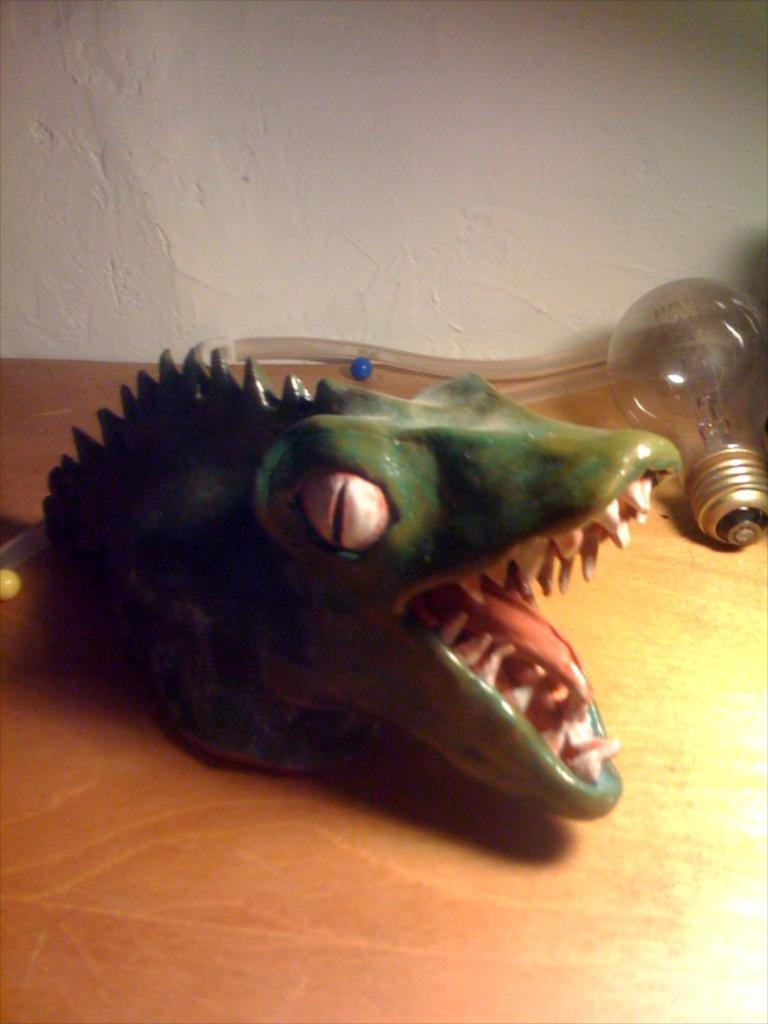What is the color of the toy in the image? The toy in the image is green. What other objects can be seen in the image? There is a bulb and a pipe in the image. What is the surface on which the objects are placed? The objects are placed on a wooden surface. What can be seen in the background of the image? There is a white color wall in the background of the image. What type of flesh can be seen in the image? There is no flesh present in the image; it features a green color toy, a bulb, a pipe, and a wooden surface. 